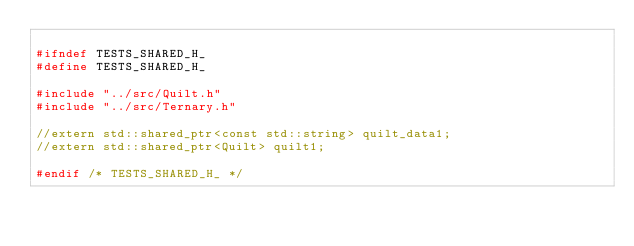Convert code to text. <code><loc_0><loc_0><loc_500><loc_500><_C_>
#ifndef TESTS_SHARED_H_
#define TESTS_SHARED_H_

#include "../src/Quilt.h"
#include "../src/Ternary.h"

//extern std::shared_ptr<const std::string> quilt_data1;
//extern std::shared_ptr<Quilt> quilt1;

#endif /* TESTS_SHARED_H_ */
</code> 